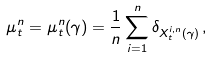Convert formula to latex. <formula><loc_0><loc_0><loc_500><loc_500>\mu ^ { n } _ { t } = \mu ^ { n } _ { t } ( \gamma ) = \frac { 1 } { n } \sum _ { i = 1 } ^ { n } \delta _ { X ^ { i , n } _ { t } ( \gamma ) } \, ,</formula> 